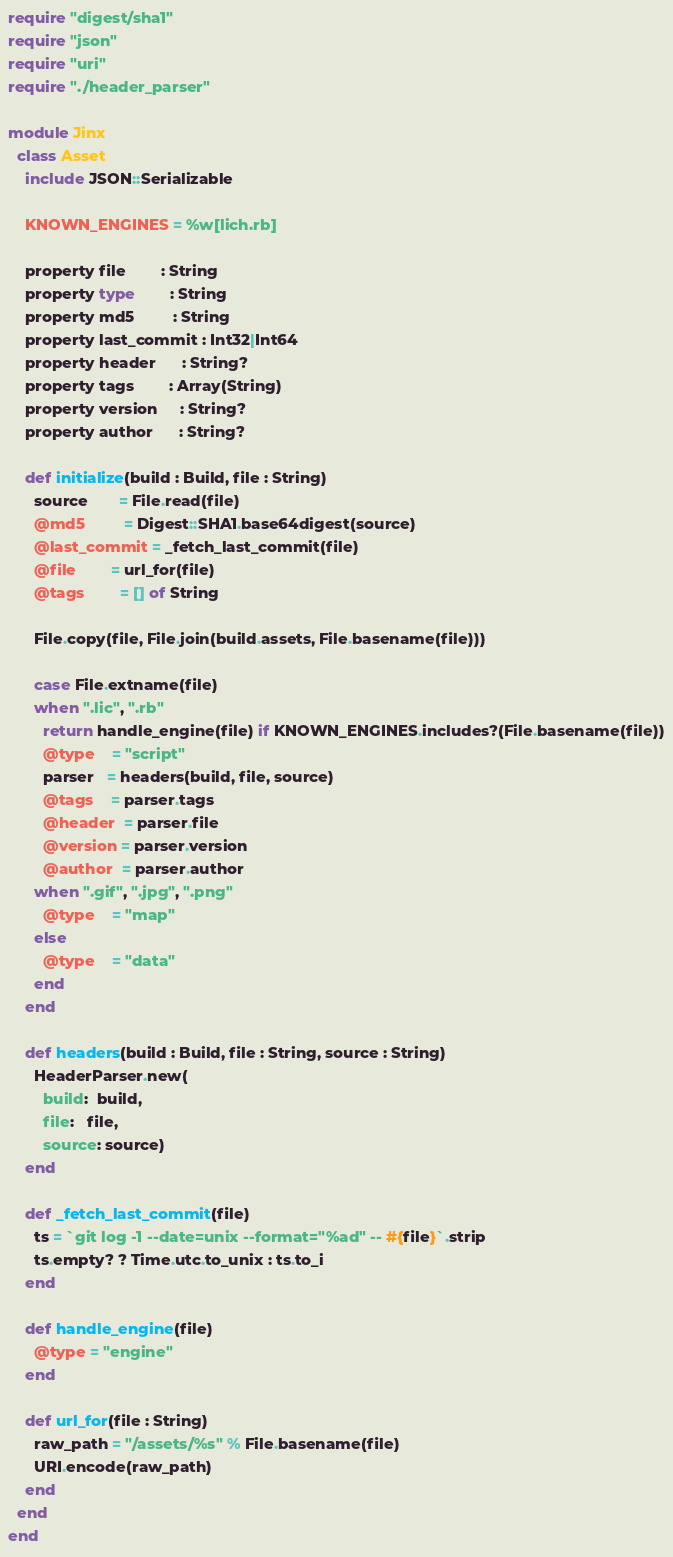Convert code to text. <code><loc_0><loc_0><loc_500><loc_500><_Crystal_>require "digest/sha1"
require "json"
require "uri"
require "./header_parser"

module Jinx
  class Asset
    include JSON::Serializable

    KNOWN_ENGINES = %w[lich.rb]

    property file        : String
    property type        : String
    property md5         : String
    property last_commit : Int32|Int64
    property header      : String?
    property tags        : Array(String)
    property version     : String?
    property author      : String?

    def initialize(build : Build, file : String)
      source       = File.read(file)
      @md5         = Digest::SHA1.base64digest(source)
      @last_commit = _fetch_last_commit(file)
      @file        = url_for(file)
      @tags        = [] of String

      File.copy(file, File.join(build.assets, File.basename(file)))

      case File.extname(file)
      when ".lic", ".rb"
        return handle_engine(file) if KNOWN_ENGINES.includes?(File.basename(file))
        @type    = "script"
        parser   = headers(build, file, source)
        @tags    = parser.tags
        @header  = parser.file
        @version = parser.version
        @author  = parser.author
      when ".gif", ".jpg", ".png"
        @type    = "map"
      else
        @type    = "data"
      end
    end

    def headers(build : Build, file : String, source : String)
      HeaderParser.new(
        build:  build,
        file:   file,
        source: source)
    end

    def _fetch_last_commit(file)
      ts = `git log -1 --date=unix --format="%ad" -- #{file}`.strip
      ts.empty? ? Time.utc.to_unix : ts.to_i
    end

    def handle_engine(file)
      @type = "engine"
    end

    def url_for(file : String)
      raw_path = "/assets/%s" % File.basename(file)
      URI.encode(raw_path)
    end
  end
end
</code> 